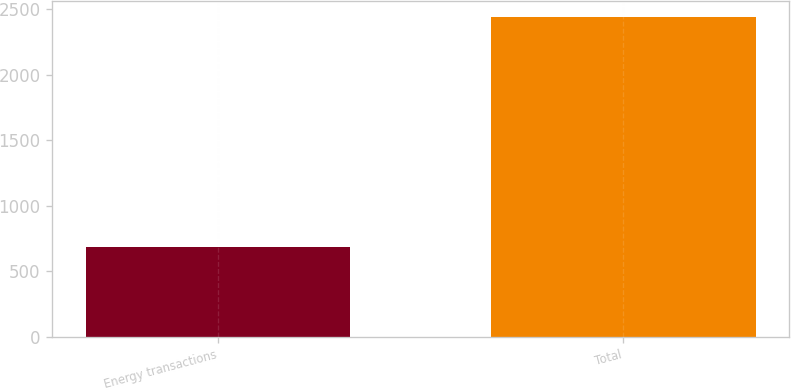Convert chart. <chart><loc_0><loc_0><loc_500><loc_500><bar_chart><fcel>Energy transactions<fcel>Total<nl><fcel>683<fcel>2439<nl></chart> 